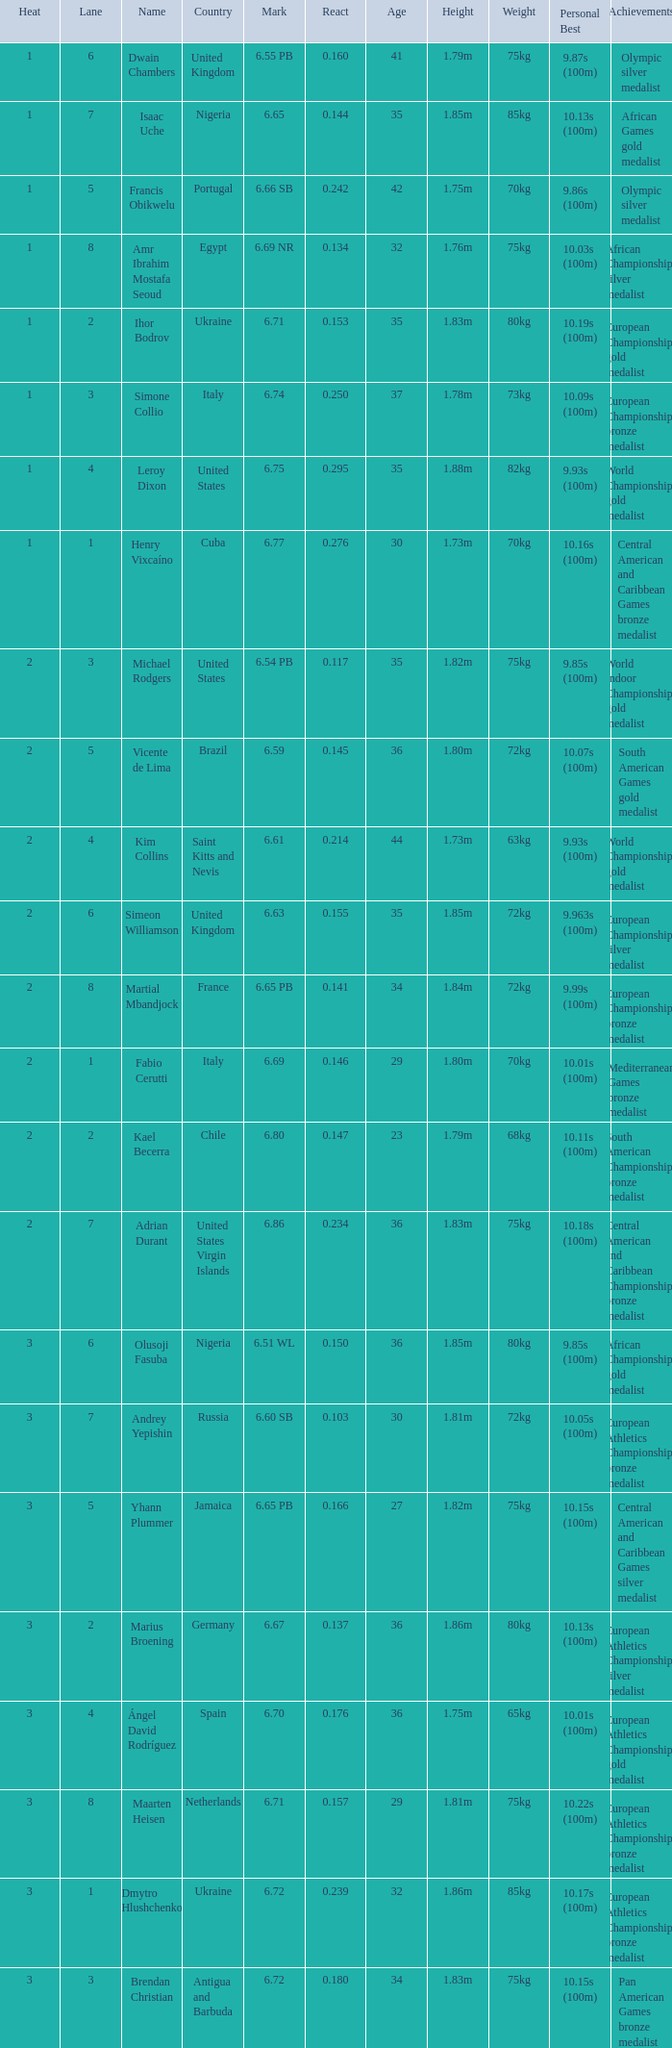Can you parse all the data within this table? {'header': ['Heat', 'Lane', 'Name', 'Country', 'Mark', 'React', 'Age', 'Height', 'Weight', 'Personal Best', 'Achievements'], 'rows': [['1', '6', 'Dwain Chambers', 'United Kingdom', '6.55 PB', '0.160', '41', '1.79m', '75kg', '9.87s (100m)', 'Olympic silver medalist'], ['1', '7', 'Isaac Uche', 'Nigeria', '6.65', '0.144', '35', '1.85m', '85kg', '10.13s (100m)', 'African Games gold medalist'], ['1', '5', 'Francis Obikwelu', 'Portugal', '6.66 SB', '0.242', '42', '1.75m', '70kg', '9.86s (100m)', 'Olympic silver medalist'], ['1', '8', 'Amr Ibrahim Mostafa Seoud', 'Egypt', '6.69 NR', '0.134', '32', '1.76m', '75kg', '10.03s (100m)', 'African Championships silver medalist'], ['1', '2', 'Ihor Bodrov', 'Ukraine', '6.71', '0.153', '35', '1.83m', '80kg', '10.19s (100m)', 'European Championships gold medalist'], ['1', '3', 'Simone Collio', 'Italy', '6.74', '0.250', '37', '1.78m', '73kg', '10.09s (100m)', 'European Championships bronze medalist'], ['1', '4', 'Leroy Dixon', 'United States', '6.75', '0.295', '35', '1.88m', '82kg', '9.93s (100m)', 'World Championships gold medalist'], ['1', '1', 'Henry Vixcaíno', 'Cuba', '6.77', '0.276', '30', '1.73m', '70kg', '10.16s (100m)', 'Central American and Caribbean Games bronze medalist'], ['2', '3', 'Michael Rodgers', 'United States', '6.54 PB', '0.117', '35', '1.82m', '75kg', '9.85s (100m)', 'World Indoor Championships gold medalist'], ['2', '5', 'Vicente de Lima', 'Brazil', '6.59', '0.145', '36', '1.80m', '72kg', '10.07s (100m)', 'South American Games gold medalist'], ['2', '4', 'Kim Collins', 'Saint Kitts and Nevis', '6.61', '0.214', '44', '1.73m', '63kg', '9.93s (100m)', 'World Championships gold medalist'], ['2', '6', 'Simeon Williamson', 'United Kingdom', '6.63', '0.155', '35', '1.85m', '72kg', '9.963s (100m)', 'European Championships silver medalist'], ['2', '8', 'Martial Mbandjock', 'France', '6.65 PB', '0.141', '34', '1.84m', '72kg', '9.99s (100m)', 'European Championships bronze medalist'], ['2', '1', 'Fabio Cerutti', 'Italy', '6.69', '0.146', '29', '1.80m', '70kg', '10.01s (100m)', 'Mediterranean Games bronze medalist'], ['2', '2', 'Kael Becerra', 'Chile', '6.80', '0.147', '23', '1.79m', '68kg', '10.11s (100m)', 'South American Championships bronze medalist'], ['2', '7', 'Adrian Durant', 'United States Virgin Islands', '6.86', '0.234', '36', '1.83m', '75kg', '10.18s (100m)', 'Central American and Caribbean Championships bronze medalist'], ['3', '6', 'Olusoji Fasuba', 'Nigeria', '6.51 WL', '0.150', '36', '1.85m', '80kg', '9.85s (100m)', 'African Championships gold medalist'], ['3', '7', 'Andrey Yepishin', 'Russia', '6.60 SB', '0.103', '30', '1.81m', '72kg', '10.05s (100m)', 'European Athletics Championships bronze medalist'], ['3', '5', 'Yhann Plummer', 'Jamaica', '6.65 PB', '0.166', '27', '1.82m', '75kg', '10.15s (100m)', 'Central American and Caribbean Games silver medalist'], ['3', '2', 'Marius Broening', 'Germany', '6.67', '0.137', '36', '1.86m', '80kg', '10.13s (100m)', 'European Athletics Championships silver medalist'], ['3', '4', 'Ángel David Rodríguez', 'Spain', '6.70', '0.176', '36', '1.75m', '65kg', '10.01s (100m)', 'European Athletics Championships gold medalist'], ['3', '8', 'Maarten Heisen', 'Netherlands', '6.71', '0.157', '29', '1.81m', '75kg', '10.22s (100m)', 'European Athletics Championships bronze medalist'], ['3', '1', 'Dmytro Hlushchenko', 'Ukraine', '6.72', '0.239', '32', '1.86m', '85kg', '10.17s (100m)', 'European Athletics Championships bronze medalist'], ['3', '3', 'Brendan Christian', 'Antigua and Barbuda', '6.72', '0.180', '34', '1.83m', '75kg', '10.15s (100m)', 'Pan American Games bronze medalist']]} What is Heat, when Mark is 6.69? 2.0. 